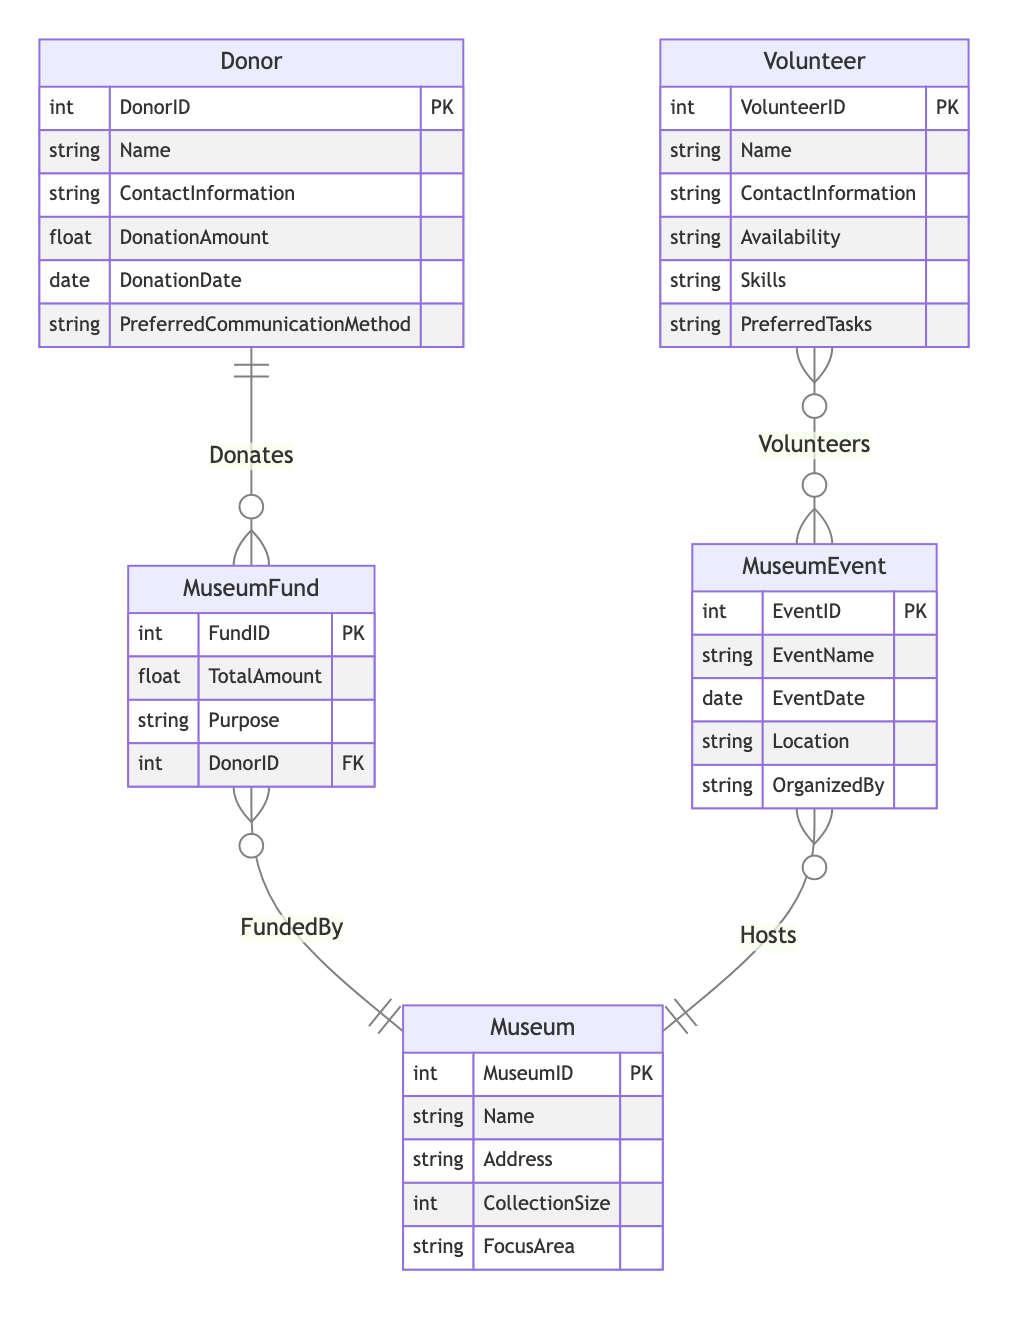What is the primary relationship between Donor and MuseumFund? The relationship indicated in the diagram between Donor and MuseumFund is "Donates", meaning that a donor contributes to the museum fund. This is a One to Many relationship as one donor can make multiple donations to the museum fund.
Answer: Donates How many entities are represented in this diagram? By counting the listed entities in the diagram, there are five: Donor, Volunteer, MuseumFund, MuseumEvent, and Museum. Therefore, the total number of entities is five.
Answer: Five What type of relationship exists between Volunteer and MuseumEvent? The relationship type specified in the diagram between Volunteer and MuseumEvent is "Volunteers", characterized as Many to Many. This indicates that multiple volunteers can be involved in various museum events.
Answer: Many to Many What is the purpose attribute of MuseumFund? The attribute "Purpose" associated with MuseumFund outlines why the fund exists. This is defined in the entity attributes of MuseumFund but requires checking the diagram to read specifics if given additional details.
Answer: Purpose Which entity does MuseumFund support? According to the relationships outlined in the diagram, MuseumFund supports the Donor entity, indicating that donations made by donors contribute to the museum fund, aligning directly as it is stated in the relationship "SupportedBy".
Answer: Donor How many different attributes does the Volunteer entity have? The Volunteer entity includes six attributes: VolunteerID, Name, ContactInformation, Availability, Skills, and PreferredTasks. By tallying these, we conclude there are six attributes listed.
Answer: Six Which entity hosts the MuseumEvent? The diagram specifies that the Museum entity hosts MuseumEvents, indicating that the museum organizes or facilitates events occurring under its name as indicated by the "Hosts" relationship.
Answer: Museum What is a potential communication method preferred by a Donor? The diagram includes an attribute for the Donor entity named "PreferredCommunicationMethod", suggesting that donors may have a specific way they prefer to be contacted regarding their donations and contributions to the museum.
Answer: PreferredCommunicationMethod How many tasks can a Volunteer perform? The relationship type between Volunteer and MuseumEvent defines their connection, indicating that a volunteer can engage in various tasks associated with different museum events since it is categorized as Many to Many. Thus, there isn't a fixed number, but multiple tasks are implied.
Answer: Many tasks 